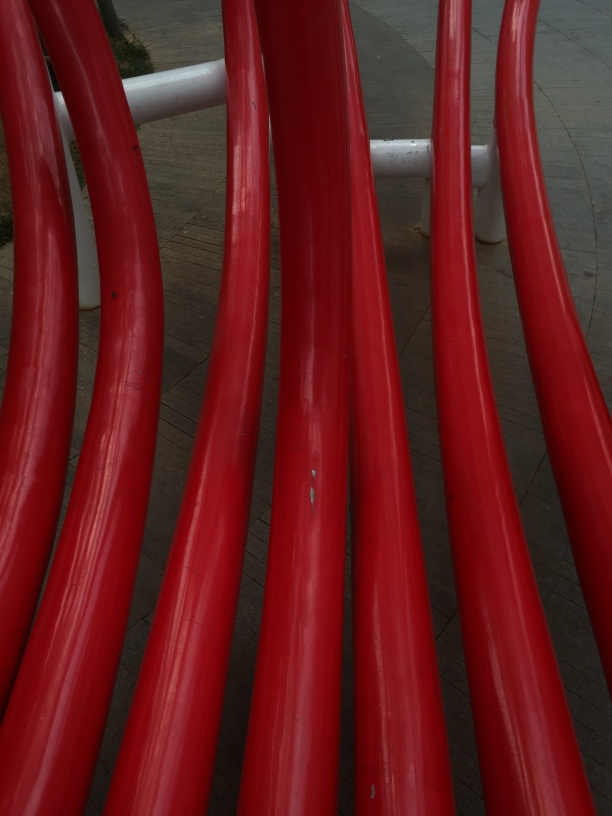What is the context or setting of this image? This image appears to be taken at an urban outdoor location, possibly depicting a piece of modern red sculptural artwork or architectural structure. The curved shapes suggest a design meant to be aesthetically pleasing or functional within a public space. 